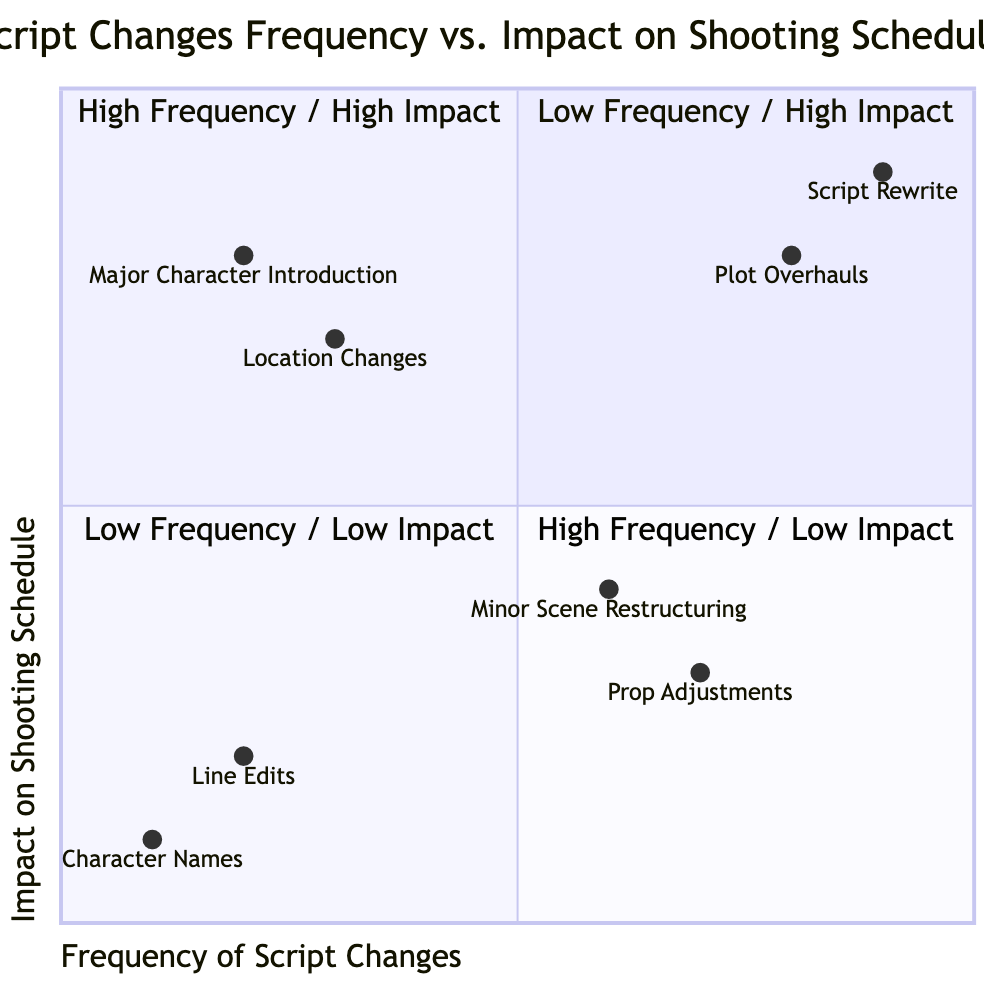What are the characteristics of the High Frequency / High Impact quadrant? This quadrant is characterized by frequent and large changes that destabilize the production schedule.
Answer: Frequent and large changes, destabilizing the production schedule What examples fall under the Low Frequency / Low Impact quadrant? The examples in this quadrant include Line Edits and Character Names, both of which are minor adjustments that do not affect core scenes.
Answer: Line Edits, Character Names Which example has the highest frequency and impact on the shooting schedule? Looking at the data points, the Script Rewrite example is plotted at the coordinates indicative of high frequency and high impact, meaning it has the most significant effect on the schedule.
Answer: Script Rewrite How many examples are in the High Frequency / Low Impact quadrant? There are two examples in the High Frequency / Low Impact quadrant: Prop Adjustments and Minor Scene Restructuring.
Answer: 2 Which quadrant contains examples that require careful rescheduling? The Low Frequency / High Impact quadrant contains examples like Major Character Introduction and Location Changes, both of which typically necessitate careful rescheduling.
Answer: Low Frequency / High Impact What is the y-axis label representing? The y-axis represents the Impact on Shooting Schedule for various types of script changes, indicating their effect on the timing of production.
Answer: Impact on Shooting Schedule What change type would be considered a minor adjustment that does not affect core scenes? Line Edits are viewed as minor adjustments that provide clarity or fit actor preferences without altering the overall core of the scenes.
Answer: Line Edits 